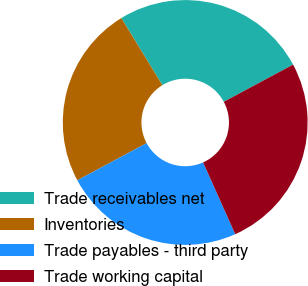<chart> <loc_0><loc_0><loc_500><loc_500><pie_chart><fcel>Trade receivables net<fcel>Inventories<fcel>Trade payables - third party<fcel>Trade working capital<nl><fcel>25.91%<fcel>24.09%<fcel>23.87%<fcel>26.13%<nl></chart> 